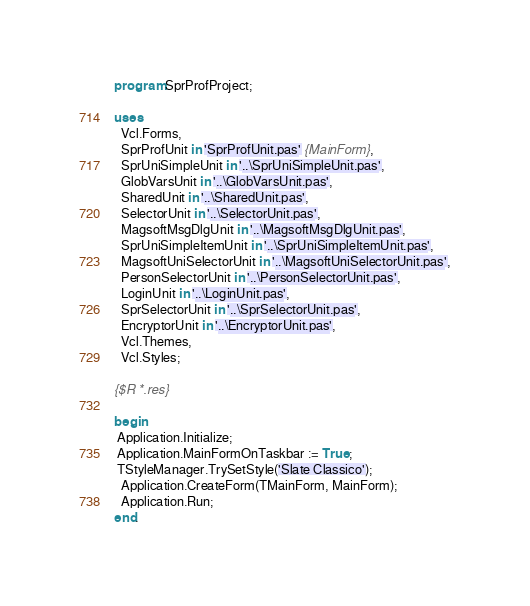<code> <loc_0><loc_0><loc_500><loc_500><_Pascal_>program SprProfProject;

uses
  Vcl.Forms,
  SprProfUnit in 'SprProfUnit.pas' {MainForm},
  SprUniSimpleUnit in '..\SprUniSimpleUnit.pas',
  GlobVarsUnit in '..\GlobVarsUnit.pas',
  SharedUnit in '..\SharedUnit.pas',
  SelectorUnit in '..\SelectorUnit.pas',
  MagsoftMsgDlgUnit in '..\MagsoftMsgDlgUnit.pas',
  SprUniSimpleItemUnit in '..\SprUniSimpleItemUnit.pas',
  MagsoftUniSelectorUnit in '..\MagsoftUniSelectorUnit.pas',
  PersonSelectorUnit in '..\PersonSelectorUnit.pas',
  LoginUnit in '..\LoginUnit.pas',
  SprSelectorUnit in '..\SprSelectorUnit.pas',
  EncryptorUnit in '..\EncryptorUnit.pas',
  Vcl.Themes,
  Vcl.Styles;

{$R *.res}

begin
 Application.Initialize;
 Application.MainFormOnTaskbar := True;
 TStyleManager.TrySetStyle('Slate Classico');
  Application.CreateForm(TMainForm, MainForm);
  Application.Run;
end.
</code> 